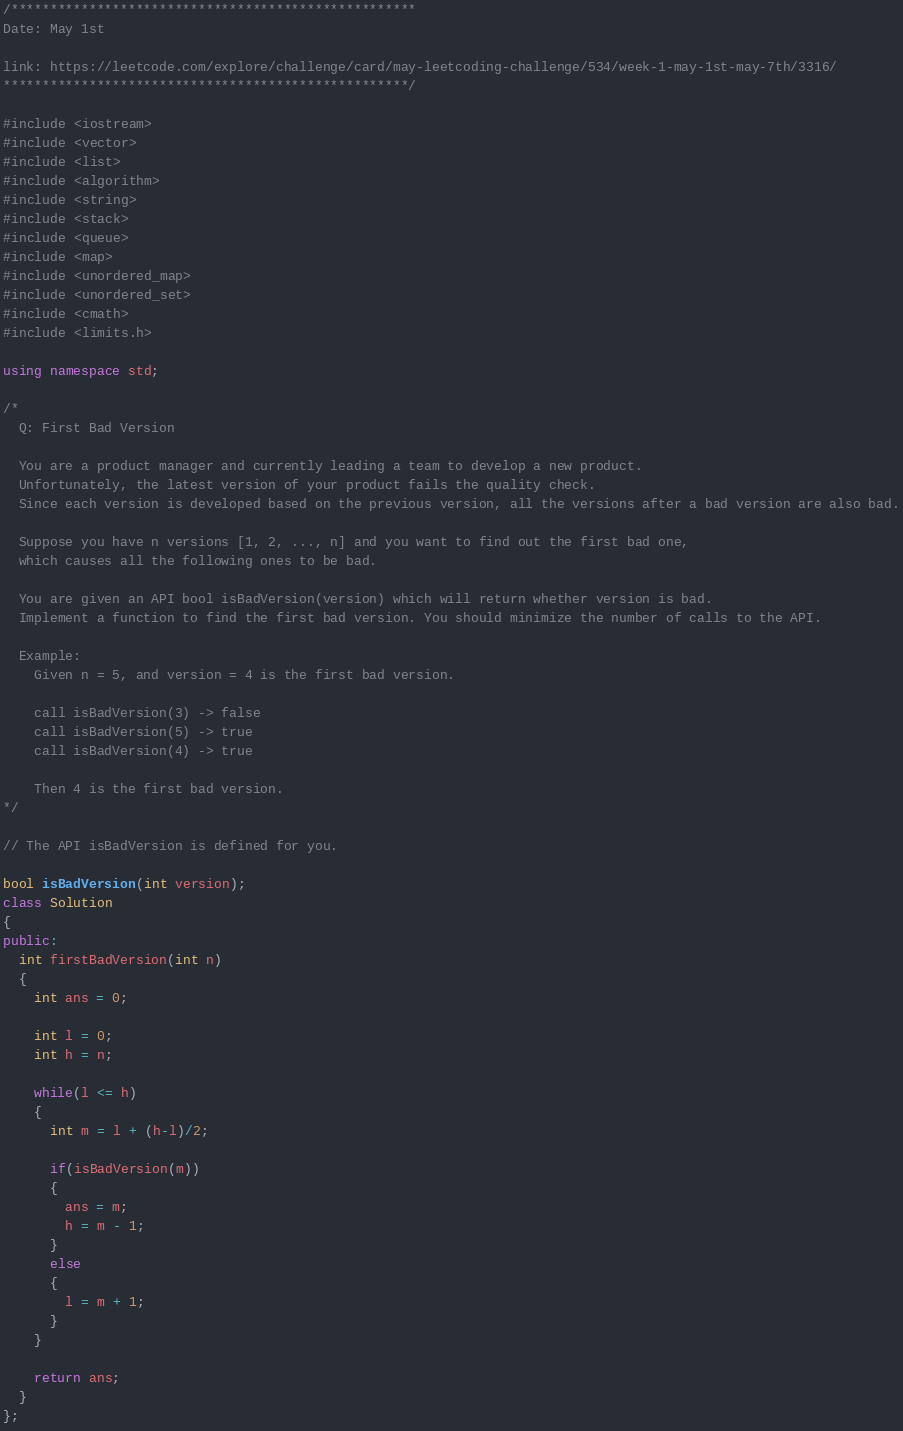<code> <loc_0><loc_0><loc_500><loc_500><_C++_>/****************************************************
Date: May 1st

link: https://leetcode.com/explore/challenge/card/may-leetcoding-challenge/534/week-1-may-1st-may-7th/3316/
****************************************************/

#include <iostream>
#include <vector>
#include <list>
#include <algorithm>
#include <string>
#include <stack>
#include <queue>
#include <map>
#include <unordered_map>
#include <unordered_set>
#include <cmath>
#include <limits.h>

using namespace std;

/*
  Q: First Bad Version

  You are a product manager and currently leading a team to develop a new product.
  Unfortunately, the latest version of your product fails the quality check.
  Since each version is developed based on the previous version, all the versions after a bad version are also bad.

  Suppose you have n versions [1, 2, ..., n] and you want to find out the first bad one,
  which causes all the following ones to be bad.

  You are given an API bool isBadVersion(version) which will return whether version is bad.
  Implement a function to find the first bad version. You should minimize the number of calls to the API.

  Example:
    Given n = 5, and version = 4 is the first bad version.

    call isBadVersion(3) -> false
    call isBadVersion(5) -> true
    call isBadVersion(4) -> true

    Then 4 is the first bad version. 
*/

// The API isBadVersion is defined for you.

bool isBadVersion(int version);
class Solution 
{
public:
  int firstBadVersion(int n) 
  {
    int ans = 0;
    
    int l = 0;
    int h = n;
    
    while(l <= h)
    {
      int m = l + (h-l)/2;
      
      if(isBadVersion(m))
      {
        ans = m;
        h = m - 1;
      }
      else
      {
        l = m + 1;
      }
    }
    
    return ans;
  }
};</code> 